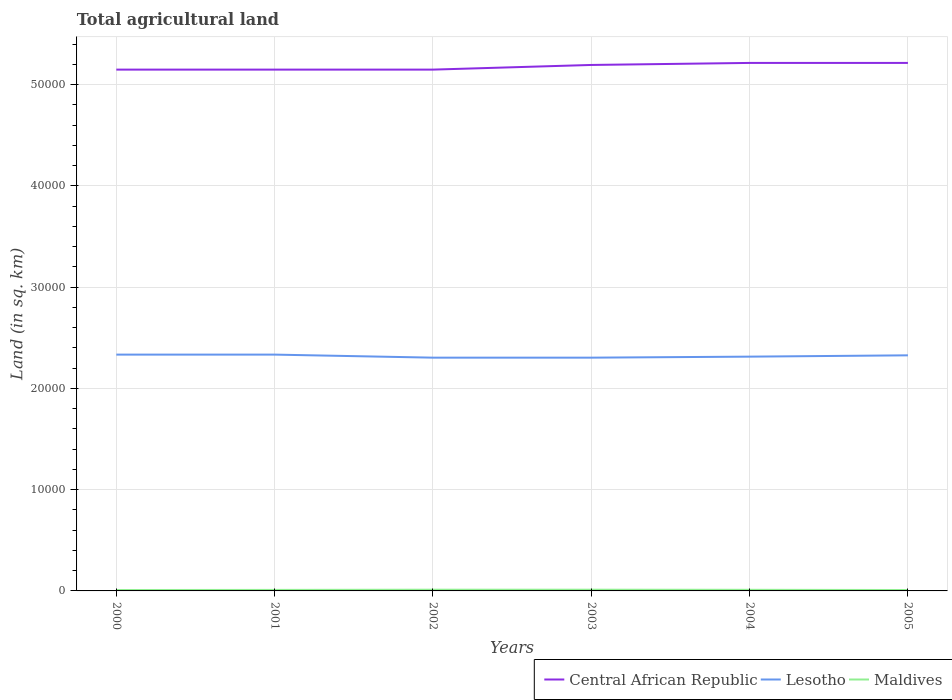Does the line corresponding to Lesotho intersect with the line corresponding to Maldives?
Provide a succinct answer. No. Is the number of lines equal to the number of legend labels?
Keep it short and to the point. Yes. Across all years, what is the maximum total agricultural land in Maldives?
Offer a very short reply. 90. What is the total total agricultural land in Maldives in the graph?
Provide a succinct answer. 10. What is the difference between the highest and the second highest total agricultural land in Lesotho?
Provide a short and direct response. 300. Does the graph contain any zero values?
Provide a short and direct response. No. Does the graph contain grids?
Provide a succinct answer. Yes. How are the legend labels stacked?
Give a very brief answer. Horizontal. What is the title of the graph?
Offer a very short reply. Total agricultural land. What is the label or title of the Y-axis?
Ensure brevity in your answer.  Land (in sq. km). What is the Land (in sq. km) of Central African Republic in 2000?
Give a very brief answer. 5.15e+04. What is the Land (in sq. km) of Lesotho in 2000?
Your answer should be very brief. 2.33e+04. What is the Land (in sq. km) in Central African Republic in 2001?
Give a very brief answer. 5.15e+04. What is the Land (in sq. km) of Lesotho in 2001?
Offer a terse response. 2.33e+04. What is the Land (in sq. km) of Maldives in 2001?
Provide a short and direct response. 100. What is the Land (in sq. km) in Central African Republic in 2002?
Your response must be concise. 5.15e+04. What is the Land (in sq. km) of Lesotho in 2002?
Give a very brief answer. 2.30e+04. What is the Land (in sq. km) of Maldives in 2002?
Offer a very short reply. 120. What is the Land (in sq. km) of Central African Republic in 2003?
Give a very brief answer. 5.20e+04. What is the Land (in sq. km) of Lesotho in 2003?
Make the answer very short. 2.30e+04. What is the Land (in sq. km) of Maldives in 2003?
Offer a very short reply. 120. What is the Land (in sq. km) in Central African Republic in 2004?
Make the answer very short. 5.22e+04. What is the Land (in sq. km) of Lesotho in 2004?
Ensure brevity in your answer.  2.31e+04. What is the Land (in sq. km) of Maldives in 2004?
Offer a terse response. 110. What is the Land (in sq. km) in Central African Republic in 2005?
Offer a very short reply. 5.22e+04. What is the Land (in sq. km) of Lesotho in 2005?
Give a very brief answer. 2.33e+04. What is the Land (in sq. km) in Maldives in 2005?
Your response must be concise. 90. Across all years, what is the maximum Land (in sq. km) of Central African Republic?
Offer a terse response. 5.22e+04. Across all years, what is the maximum Land (in sq. km) in Lesotho?
Make the answer very short. 2.33e+04. Across all years, what is the maximum Land (in sq. km) in Maldives?
Your response must be concise. 120. Across all years, what is the minimum Land (in sq. km) in Central African Republic?
Give a very brief answer. 5.15e+04. Across all years, what is the minimum Land (in sq. km) in Lesotho?
Keep it short and to the point. 2.30e+04. Across all years, what is the minimum Land (in sq. km) of Maldives?
Keep it short and to the point. 90. What is the total Land (in sq. km) in Central African Republic in the graph?
Provide a short and direct response. 3.11e+05. What is the total Land (in sq. km) of Lesotho in the graph?
Provide a short and direct response. 1.39e+05. What is the total Land (in sq. km) of Maldives in the graph?
Your response must be concise. 630. What is the difference between the Land (in sq. km) in Lesotho in 2000 and that in 2001?
Keep it short and to the point. 0. What is the difference between the Land (in sq. km) of Central African Republic in 2000 and that in 2002?
Give a very brief answer. 0. What is the difference between the Land (in sq. km) of Lesotho in 2000 and that in 2002?
Make the answer very short. 300. What is the difference between the Land (in sq. km) of Maldives in 2000 and that in 2002?
Ensure brevity in your answer.  -30. What is the difference between the Land (in sq. km) of Central African Republic in 2000 and that in 2003?
Your answer should be compact. -460. What is the difference between the Land (in sq. km) of Lesotho in 2000 and that in 2003?
Provide a short and direct response. 300. What is the difference between the Land (in sq. km) of Maldives in 2000 and that in 2003?
Your answer should be very brief. -30. What is the difference between the Land (in sq. km) of Central African Republic in 2000 and that in 2004?
Your answer should be very brief. -660. What is the difference between the Land (in sq. km) of Lesotho in 2000 and that in 2004?
Keep it short and to the point. 200. What is the difference between the Land (in sq. km) of Central African Republic in 2000 and that in 2005?
Your response must be concise. -660. What is the difference between the Land (in sq. km) in Central African Republic in 2001 and that in 2002?
Your response must be concise. 0. What is the difference between the Land (in sq. km) of Lesotho in 2001 and that in 2002?
Your response must be concise. 300. What is the difference between the Land (in sq. km) of Maldives in 2001 and that in 2002?
Offer a terse response. -20. What is the difference between the Land (in sq. km) in Central African Republic in 2001 and that in 2003?
Your answer should be compact. -460. What is the difference between the Land (in sq. km) in Lesotho in 2001 and that in 2003?
Provide a succinct answer. 300. What is the difference between the Land (in sq. km) in Maldives in 2001 and that in 2003?
Offer a terse response. -20. What is the difference between the Land (in sq. km) of Central African Republic in 2001 and that in 2004?
Keep it short and to the point. -660. What is the difference between the Land (in sq. km) in Lesotho in 2001 and that in 2004?
Offer a terse response. 200. What is the difference between the Land (in sq. km) of Maldives in 2001 and that in 2004?
Provide a short and direct response. -10. What is the difference between the Land (in sq. km) in Central African Republic in 2001 and that in 2005?
Offer a terse response. -660. What is the difference between the Land (in sq. km) in Lesotho in 2001 and that in 2005?
Provide a succinct answer. 70. What is the difference between the Land (in sq. km) of Maldives in 2001 and that in 2005?
Give a very brief answer. 10. What is the difference between the Land (in sq. km) of Central African Republic in 2002 and that in 2003?
Give a very brief answer. -460. What is the difference between the Land (in sq. km) in Lesotho in 2002 and that in 2003?
Your response must be concise. 0. What is the difference between the Land (in sq. km) of Central African Republic in 2002 and that in 2004?
Offer a very short reply. -660. What is the difference between the Land (in sq. km) of Lesotho in 2002 and that in 2004?
Offer a very short reply. -100. What is the difference between the Land (in sq. km) of Maldives in 2002 and that in 2004?
Make the answer very short. 10. What is the difference between the Land (in sq. km) in Central African Republic in 2002 and that in 2005?
Keep it short and to the point. -660. What is the difference between the Land (in sq. km) in Lesotho in 2002 and that in 2005?
Offer a terse response. -230. What is the difference between the Land (in sq. km) in Maldives in 2002 and that in 2005?
Your response must be concise. 30. What is the difference between the Land (in sq. km) in Central African Republic in 2003 and that in 2004?
Provide a short and direct response. -200. What is the difference between the Land (in sq. km) of Lesotho in 2003 and that in 2004?
Your response must be concise. -100. What is the difference between the Land (in sq. km) of Maldives in 2003 and that in 2004?
Provide a succinct answer. 10. What is the difference between the Land (in sq. km) in Central African Republic in 2003 and that in 2005?
Your response must be concise. -200. What is the difference between the Land (in sq. km) in Lesotho in 2003 and that in 2005?
Offer a very short reply. -230. What is the difference between the Land (in sq. km) in Maldives in 2003 and that in 2005?
Your answer should be compact. 30. What is the difference between the Land (in sq. km) in Lesotho in 2004 and that in 2005?
Your answer should be compact. -130. What is the difference between the Land (in sq. km) of Central African Republic in 2000 and the Land (in sq. km) of Lesotho in 2001?
Offer a very short reply. 2.82e+04. What is the difference between the Land (in sq. km) of Central African Republic in 2000 and the Land (in sq. km) of Maldives in 2001?
Your answer should be compact. 5.14e+04. What is the difference between the Land (in sq. km) in Lesotho in 2000 and the Land (in sq. km) in Maldives in 2001?
Your answer should be very brief. 2.32e+04. What is the difference between the Land (in sq. km) of Central African Republic in 2000 and the Land (in sq. km) of Lesotho in 2002?
Your answer should be very brief. 2.84e+04. What is the difference between the Land (in sq. km) of Central African Republic in 2000 and the Land (in sq. km) of Maldives in 2002?
Your answer should be compact. 5.14e+04. What is the difference between the Land (in sq. km) of Lesotho in 2000 and the Land (in sq. km) of Maldives in 2002?
Ensure brevity in your answer.  2.32e+04. What is the difference between the Land (in sq. km) in Central African Republic in 2000 and the Land (in sq. km) in Lesotho in 2003?
Make the answer very short. 2.84e+04. What is the difference between the Land (in sq. km) of Central African Republic in 2000 and the Land (in sq. km) of Maldives in 2003?
Your answer should be very brief. 5.14e+04. What is the difference between the Land (in sq. km) in Lesotho in 2000 and the Land (in sq. km) in Maldives in 2003?
Offer a terse response. 2.32e+04. What is the difference between the Land (in sq. km) in Central African Republic in 2000 and the Land (in sq. km) in Lesotho in 2004?
Make the answer very short. 2.84e+04. What is the difference between the Land (in sq. km) in Central African Republic in 2000 and the Land (in sq. km) in Maldives in 2004?
Provide a short and direct response. 5.14e+04. What is the difference between the Land (in sq. km) in Lesotho in 2000 and the Land (in sq. km) in Maldives in 2004?
Give a very brief answer. 2.32e+04. What is the difference between the Land (in sq. km) in Central African Republic in 2000 and the Land (in sq. km) in Lesotho in 2005?
Give a very brief answer. 2.82e+04. What is the difference between the Land (in sq. km) in Central African Republic in 2000 and the Land (in sq. km) in Maldives in 2005?
Your response must be concise. 5.14e+04. What is the difference between the Land (in sq. km) in Lesotho in 2000 and the Land (in sq. km) in Maldives in 2005?
Offer a terse response. 2.32e+04. What is the difference between the Land (in sq. km) in Central African Republic in 2001 and the Land (in sq. km) in Lesotho in 2002?
Keep it short and to the point. 2.84e+04. What is the difference between the Land (in sq. km) in Central African Republic in 2001 and the Land (in sq. km) in Maldives in 2002?
Ensure brevity in your answer.  5.14e+04. What is the difference between the Land (in sq. km) in Lesotho in 2001 and the Land (in sq. km) in Maldives in 2002?
Your response must be concise. 2.32e+04. What is the difference between the Land (in sq. km) in Central African Republic in 2001 and the Land (in sq. km) in Lesotho in 2003?
Your response must be concise. 2.84e+04. What is the difference between the Land (in sq. km) of Central African Republic in 2001 and the Land (in sq. km) of Maldives in 2003?
Offer a very short reply. 5.14e+04. What is the difference between the Land (in sq. km) of Lesotho in 2001 and the Land (in sq. km) of Maldives in 2003?
Make the answer very short. 2.32e+04. What is the difference between the Land (in sq. km) of Central African Republic in 2001 and the Land (in sq. km) of Lesotho in 2004?
Provide a succinct answer. 2.84e+04. What is the difference between the Land (in sq. km) in Central African Republic in 2001 and the Land (in sq. km) in Maldives in 2004?
Your response must be concise. 5.14e+04. What is the difference between the Land (in sq. km) of Lesotho in 2001 and the Land (in sq. km) of Maldives in 2004?
Keep it short and to the point. 2.32e+04. What is the difference between the Land (in sq. km) of Central African Republic in 2001 and the Land (in sq. km) of Lesotho in 2005?
Give a very brief answer. 2.82e+04. What is the difference between the Land (in sq. km) in Central African Republic in 2001 and the Land (in sq. km) in Maldives in 2005?
Make the answer very short. 5.14e+04. What is the difference between the Land (in sq. km) of Lesotho in 2001 and the Land (in sq. km) of Maldives in 2005?
Ensure brevity in your answer.  2.32e+04. What is the difference between the Land (in sq. km) of Central African Republic in 2002 and the Land (in sq. km) of Lesotho in 2003?
Offer a terse response. 2.84e+04. What is the difference between the Land (in sq. km) in Central African Republic in 2002 and the Land (in sq. km) in Maldives in 2003?
Make the answer very short. 5.14e+04. What is the difference between the Land (in sq. km) of Lesotho in 2002 and the Land (in sq. km) of Maldives in 2003?
Your response must be concise. 2.29e+04. What is the difference between the Land (in sq. km) in Central African Republic in 2002 and the Land (in sq. km) in Lesotho in 2004?
Make the answer very short. 2.84e+04. What is the difference between the Land (in sq. km) of Central African Republic in 2002 and the Land (in sq. km) of Maldives in 2004?
Give a very brief answer. 5.14e+04. What is the difference between the Land (in sq. km) in Lesotho in 2002 and the Land (in sq. km) in Maldives in 2004?
Offer a very short reply. 2.29e+04. What is the difference between the Land (in sq. km) of Central African Republic in 2002 and the Land (in sq. km) of Lesotho in 2005?
Offer a very short reply. 2.82e+04. What is the difference between the Land (in sq. km) of Central African Republic in 2002 and the Land (in sq. km) of Maldives in 2005?
Make the answer very short. 5.14e+04. What is the difference between the Land (in sq. km) in Lesotho in 2002 and the Land (in sq. km) in Maldives in 2005?
Make the answer very short. 2.30e+04. What is the difference between the Land (in sq. km) of Central African Republic in 2003 and the Land (in sq. km) of Lesotho in 2004?
Offer a very short reply. 2.88e+04. What is the difference between the Land (in sq. km) of Central African Republic in 2003 and the Land (in sq. km) of Maldives in 2004?
Make the answer very short. 5.18e+04. What is the difference between the Land (in sq. km) of Lesotho in 2003 and the Land (in sq. km) of Maldives in 2004?
Keep it short and to the point. 2.29e+04. What is the difference between the Land (in sq. km) in Central African Republic in 2003 and the Land (in sq. km) in Lesotho in 2005?
Your response must be concise. 2.87e+04. What is the difference between the Land (in sq. km) in Central African Republic in 2003 and the Land (in sq. km) in Maldives in 2005?
Your answer should be very brief. 5.19e+04. What is the difference between the Land (in sq. km) in Lesotho in 2003 and the Land (in sq. km) in Maldives in 2005?
Make the answer very short. 2.30e+04. What is the difference between the Land (in sq. km) in Central African Republic in 2004 and the Land (in sq. km) in Lesotho in 2005?
Provide a short and direct response. 2.89e+04. What is the difference between the Land (in sq. km) in Central African Republic in 2004 and the Land (in sq. km) in Maldives in 2005?
Offer a very short reply. 5.21e+04. What is the difference between the Land (in sq. km) of Lesotho in 2004 and the Land (in sq. km) of Maldives in 2005?
Offer a terse response. 2.30e+04. What is the average Land (in sq. km) of Central African Republic per year?
Offer a terse response. 5.18e+04. What is the average Land (in sq. km) in Lesotho per year?
Make the answer very short. 2.32e+04. What is the average Land (in sq. km) in Maldives per year?
Offer a very short reply. 105. In the year 2000, what is the difference between the Land (in sq. km) of Central African Republic and Land (in sq. km) of Lesotho?
Offer a very short reply. 2.82e+04. In the year 2000, what is the difference between the Land (in sq. km) in Central African Republic and Land (in sq. km) in Maldives?
Offer a terse response. 5.14e+04. In the year 2000, what is the difference between the Land (in sq. km) of Lesotho and Land (in sq. km) of Maldives?
Ensure brevity in your answer.  2.32e+04. In the year 2001, what is the difference between the Land (in sq. km) of Central African Republic and Land (in sq. km) of Lesotho?
Keep it short and to the point. 2.82e+04. In the year 2001, what is the difference between the Land (in sq. km) in Central African Republic and Land (in sq. km) in Maldives?
Offer a terse response. 5.14e+04. In the year 2001, what is the difference between the Land (in sq. km) of Lesotho and Land (in sq. km) of Maldives?
Offer a terse response. 2.32e+04. In the year 2002, what is the difference between the Land (in sq. km) in Central African Republic and Land (in sq. km) in Lesotho?
Offer a terse response. 2.84e+04. In the year 2002, what is the difference between the Land (in sq. km) in Central African Republic and Land (in sq. km) in Maldives?
Provide a short and direct response. 5.14e+04. In the year 2002, what is the difference between the Land (in sq. km) in Lesotho and Land (in sq. km) in Maldives?
Your answer should be very brief. 2.29e+04. In the year 2003, what is the difference between the Land (in sq. km) in Central African Republic and Land (in sq. km) in Lesotho?
Make the answer very short. 2.89e+04. In the year 2003, what is the difference between the Land (in sq. km) of Central African Republic and Land (in sq. km) of Maldives?
Make the answer very short. 5.18e+04. In the year 2003, what is the difference between the Land (in sq. km) in Lesotho and Land (in sq. km) in Maldives?
Offer a terse response. 2.29e+04. In the year 2004, what is the difference between the Land (in sq. km) of Central African Republic and Land (in sq. km) of Lesotho?
Offer a terse response. 2.90e+04. In the year 2004, what is the difference between the Land (in sq. km) in Central African Republic and Land (in sq. km) in Maldives?
Your response must be concise. 5.20e+04. In the year 2004, what is the difference between the Land (in sq. km) of Lesotho and Land (in sq. km) of Maldives?
Provide a succinct answer. 2.30e+04. In the year 2005, what is the difference between the Land (in sq. km) of Central African Republic and Land (in sq. km) of Lesotho?
Your answer should be compact. 2.89e+04. In the year 2005, what is the difference between the Land (in sq. km) in Central African Republic and Land (in sq. km) in Maldives?
Give a very brief answer. 5.21e+04. In the year 2005, what is the difference between the Land (in sq. km) in Lesotho and Land (in sq. km) in Maldives?
Your response must be concise. 2.32e+04. What is the ratio of the Land (in sq. km) of Central African Republic in 2000 to that in 2001?
Offer a very short reply. 1. What is the ratio of the Land (in sq. km) in Lesotho in 2000 to that in 2001?
Make the answer very short. 1. What is the ratio of the Land (in sq. km) of Maldives in 2000 to that in 2002?
Your answer should be compact. 0.75. What is the ratio of the Land (in sq. km) of Central African Republic in 2000 to that in 2004?
Ensure brevity in your answer.  0.99. What is the ratio of the Land (in sq. km) in Lesotho in 2000 to that in 2004?
Give a very brief answer. 1.01. What is the ratio of the Land (in sq. km) of Maldives in 2000 to that in 2004?
Give a very brief answer. 0.82. What is the ratio of the Land (in sq. km) of Central African Republic in 2000 to that in 2005?
Offer a terse response. 0.99. What is the ratio of the Land (in sq. km) of Lesotho in 2000 to that in 2005?
Keep it short and to the point. 1. What is the ratio of the Land (in sq. km) in Central African Republic in 2001 to that in 2002?
Give a very brief answer. 1. What is the ratio of the Land (in sq. km) of Central African Republic in 2001 to that in 2003?
Your response must be concise. 0.99. What is the ratio of the Land (in sq. km) in Maldives in 2001 to that in 2003?
Keep it short and to the point. 0.83. What is the ratio of the Land (in sq. km) of Central African Republic in 2001 to that in 2004?
Offer a terse response. 0.99. What is the ratio of the Land (in sq. km) in Lesotho in 2001 to that in 2004?
Ensure brevity in your answer.  1.01. What is the ratio of the Land (in sq. km) of Central African Republic in 2001 to that in 2005?
Your answer should be compact. 0.99. What is the ratio of the Land (in sq. km) in Lesotho in 2001 to that in 2005?
Keep it short and to the point. 1. What is the ratio of the Land (in sq. km) in Central African Republic in 2002 to that in 2003?
Provide a succinct answer. 0.99. What is the ratio of the Land (in sq. km) in Lesotho in 2002 to that in 2003?
Offer a terse response. 1. What is the ratio of the Land (in sq. km) of Maldives in 2002 to that in 2003?
Your response must be concise. 1. What is the ratio of the Land (in sq. km) of Central African Republic in 2002 to that in 2004?
Your response must be concise. 0.99. What is the ratio of the Land (in sq. km) of Central African Republic in 2002 to that in 2005?
Offer a terse response. 0.99. What is the ratio of the Land (in sq. km) in Lesotho in 2002 to that in 2005?
Make the answer very short. 0.99. What is the ratio of the Land (in sq. km) of Maldives in 2003 to that in 2004?
Ensure brevity in your answer.  1.09. What is the ratio of the Land (in sq. km) of Central African Republic in 2003 to that in 2005?
Keep it short and to the point. 1. What is the ratio of the Land (in sq. km) in Lesotho in 2003 to that in 2005?
Give a very brief answer. 0.99. What is the ratio of the Land (in sq. km) in Maldives in 2003 to that in 2005?
Provide a short and direct response. 1.33. What is the ratio of the Land (in sq. km) in Lesotho in 2004 to that in 2005?
Keep it short and to the point. 0.99. What is the ratio of the Land (in sq. km) in Maldives in 2004 to that in 2005?
Give a very brief answer. 1.22. What is the difference between the highest and the second highest Land (in sq. km) of Lesotho?
Your answer should be compact. 0. What is the difference between the highest and the second highest Land (in sq. km) of Maldives?
Keep it short and to the point. 0. What is the difference between the highest and the lowest Land (in sq. km) of Central African Republic?
Make the answer very short. 660. What is the difference between the highest and the lowest Land (in sq. km) in Lesotho?
Ensure brevity in your answer.  300. 